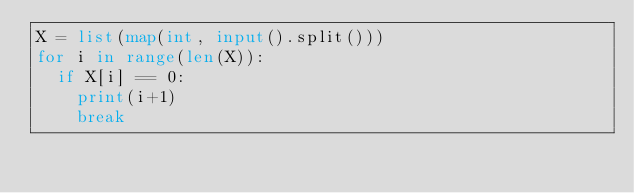<code> <loc_0><loc_0><loc_500><loc_500><_Python_>X = list(map(int, input().split()))
for i in range(len(X)):
  if X[i] == 0:
    print(i+1)
    break</code> 